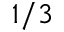Convert formula to latex. <formula><loc_0><loc_0><loc_500><loc_500>1 / 3</formula> 